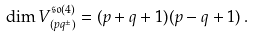<formula> <loc_0><loc_0><loc_500><loc_500>\dim V ^ { \mathfrak { s o } ( 4 ) } _ { ( p q ^ { \pm } ) } = ( p + q + 1 ) ( p - q + 1 ) \, .</formula> 